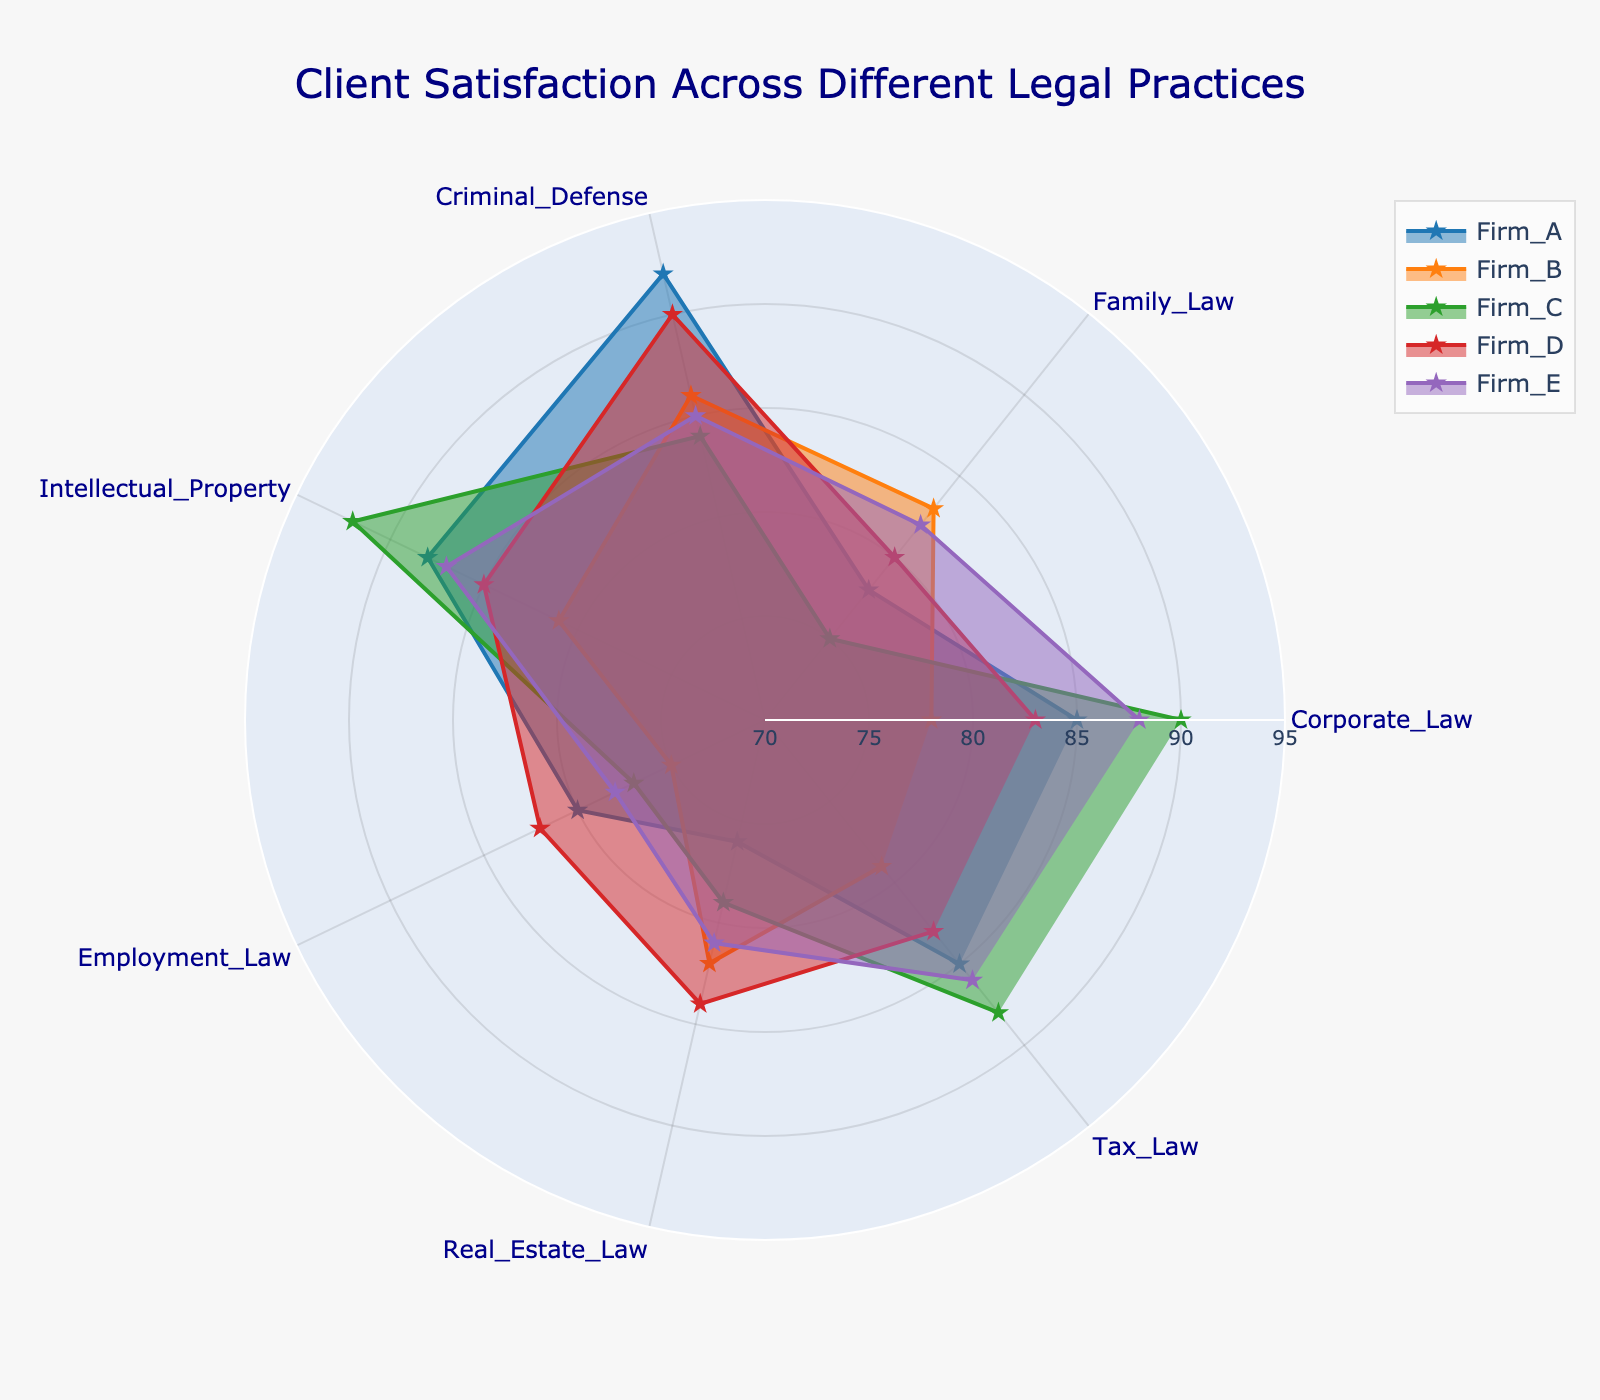What is the title of the radar chart? The title of the radar chart is placed prominently at the top of the figure. It reads, "Client Satisfaction Across Different Legal Practices."
Answer: Client Satisfaction Across Different Legal Practices How many legal practices are evaluated in the radar chart? By counting the categories listed around the radar chart, one can see that there are seven distinct legal practices evaluated in this figure.
Answer: Seven Which firm has the highest satisfaction in Criminal Defense? The satisfaction scores for Criminal Defense are placed along the corresponding axis. Firm A has a score of 92, which is the highest among all firms for this practice.
Answer: Firm A What is the average client satisfaction score for Firm E across all legal practices? To find the average, add up Firm E's scores (88, 82, 85, 87, 78, 81, 86) and divide by the number of practices (7). Thus, the sum is 587, and the average is 587/7 = 83.86.
Answer: 83.86 Which firm has the most balanced satisfaction scores across different legal practices? A firm with similar lengths of radii for different practices would appear balanced. Firm D’s scores (83, 80, 90, 85, 82, 84, 83) are relatively close to each other, indicating balance.
Answer: Firm D What is the range of client satisfaction scores for Corporate Law across all firms? Identify the highest and lowest scores for Corporate Law from the chart. Firm C has the highest score with 90, and Firm B has the lowest score with 78. Therefore, the range is 90 - 78 = 12.
Answer: 12 Which firm performs the best in Intellectual Property? By looking at the scores along the Intellectual Property axis, Firm C has the highest score with 92, making it the top performer in this practice.
Answer: Firm C Compare the client satisfaction in Family Law between Firm A and Firm B. Which firm scores higher and by how much? Firm A scores 78 in Family Law, while Firm B scores 83. The difference is 83 - 78 = 5. Firm B scores higher by 5 points.
Answer: Firm B by 5 points Which firm has the lowest satisfaction score in any category, and in which category is it? Reviewing the chart, the lowest score appears for Firm C in Family Law, which is 75.
Answer: Firm C in Family Law What is the median satisfaction score for Real Estate Law across all firms? List the scores for Real Estate Law (76, 82, 79, 84, 81) and arrange them in order: 76, 79, 81, 82, 84. The median score is the middle value, which is 81.
Answer: 81 